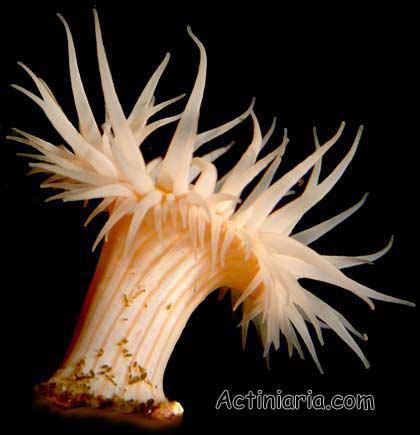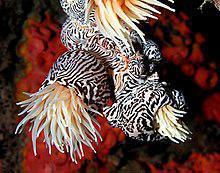The first image is the image on the left, the second image is the image on the right. Analyze the images presented: Is the assertion "One image features a peach-colored anemone with a thick stalk, and the other shows anemone with a black-and-white zebra-look pattern on the stalk." valid? Answer yes or no. Yes. 